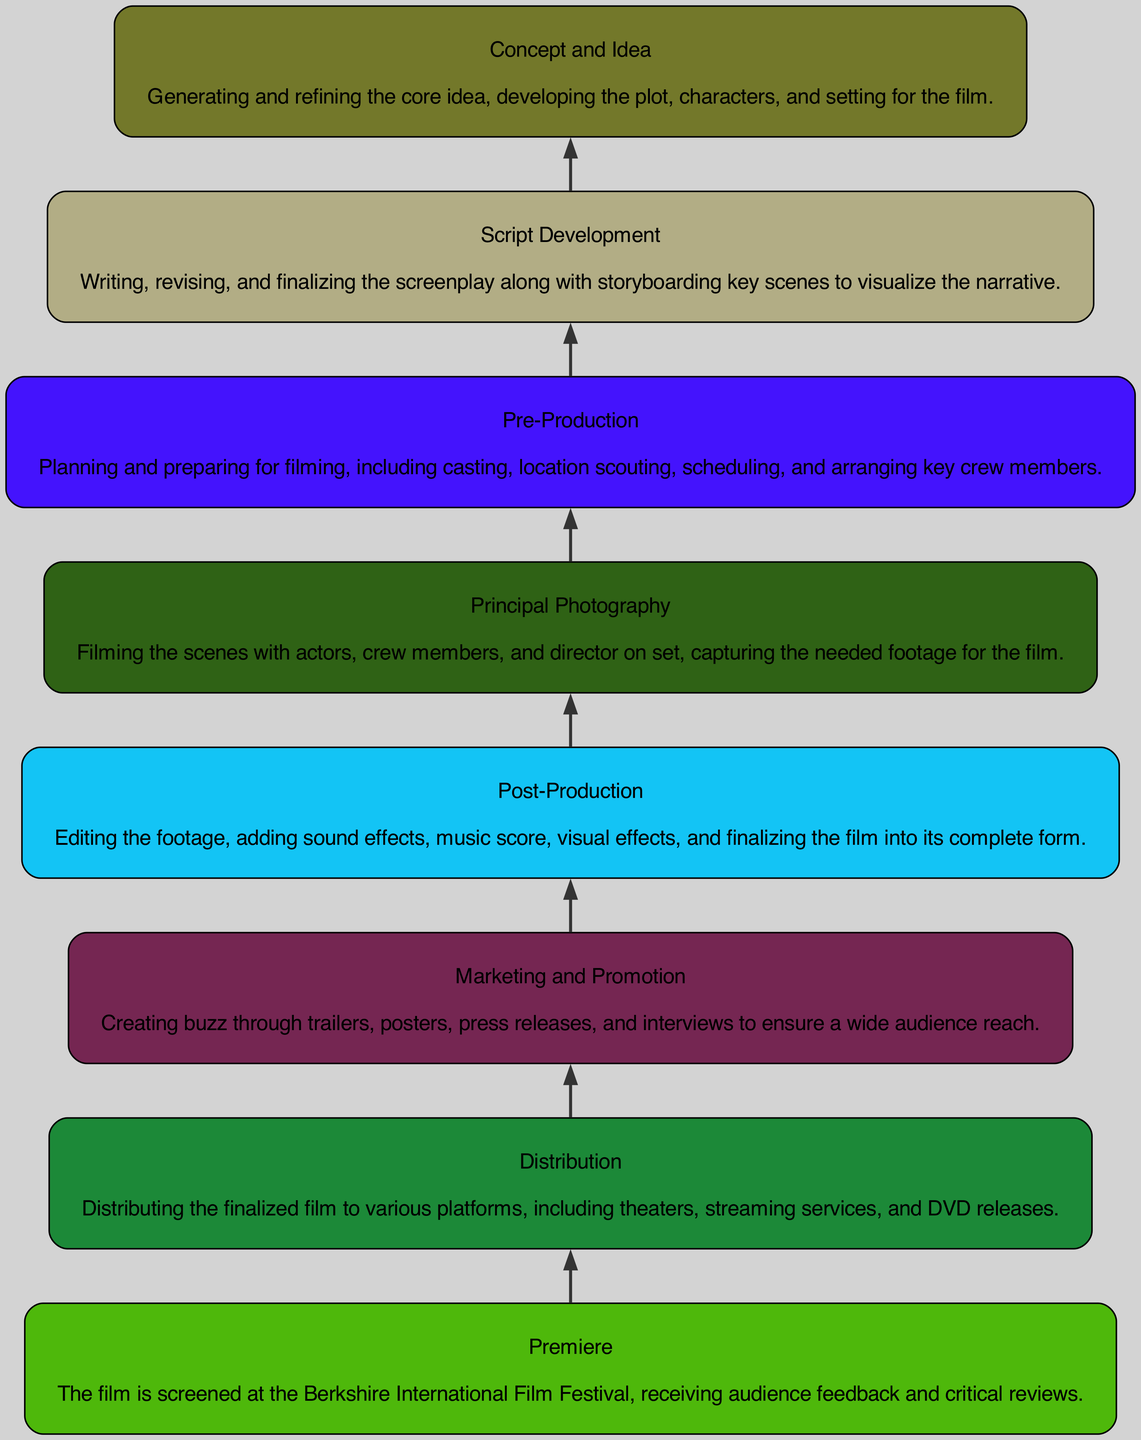What is the first step in the film production process? The diagram starts with the node labeled "Concept and Idea", indicating that it is the initial stage in the film production process.
Answer: Concept and Idea How many total nodes are present in the diagram? There are eight nodes in total, as seen in the diagram's structure that outlines each stage of the film production process from concept to premiere.
Answer: 8 Which node comes immediately after Script Development? The flow of the diagram indicates that the node following "Script Development" is "Pre-Production," as arrows direct the viewer upward through the process.
Answer: Pre-Production What process follows Post-Production? According to the diagram, the "Distribution" node follows "Post-Production," as it is the next step in the film's journey after completing the editing and final touches of the film.
Answer: Distribution What is the last step before the film's premiere? The diagram shows the node "Distribution" immediately before "Premiere," indicating that the film must be distributed before it can be premiered at the festival.
Answer: Distribution Which node is positioned fifth in the flow of the diagram? Counting from the bottom of the diagram, "Principal Photography" is the fifth node, as it is positioned above four other nodes that lead to it in the filming process.
Answer: Principal Photography What is the main activity in the node labeled "Post-Production"? The description for "Post-Production" highlights the activity of editing the footage, which implies that this phase includes various editing steps to finalize the film.
Answer: Editing the footage How many steps are required from Concept to Premiere? The flow from "Concept and Idea" to "Premiere" involves all eight nodes, indicating that there are seven steps in between the initial concept and the film's premiere.
Answer: 7 steps What kind of marketing occurs before the film's premiere? The "Marketing and Promotion" node, located in the diagram, emphasizes creating buzz through various promotional activities leading up to the film's screening.
Answer: Creating buzz through trailers, posters, press releases, and interviews 